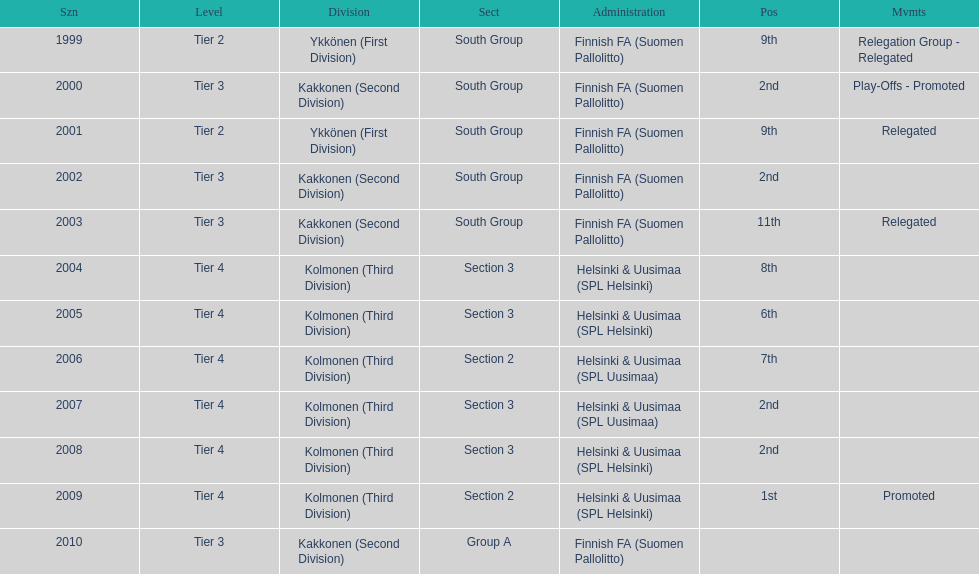How many 2nd positions were there? 4. 